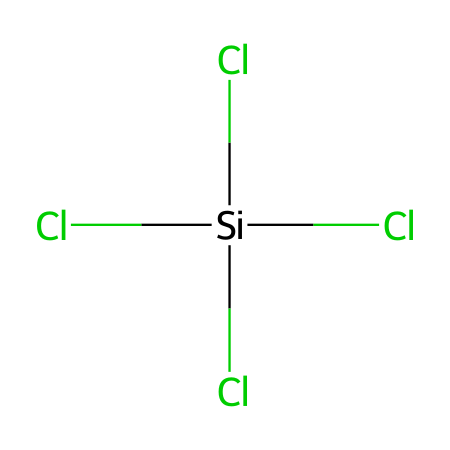What is the name of this chemical? The SMILES representation signifies that the chemical consists of a silicon atom bonded to four chlorine atoms, which is the definition of tetrachlorosilane.
Answer: tetrachlorosilane How many chlorine atoms are present in this molecule? By examining the SMILES structure, we can count four chlorine (Cl) atoms that are directly attached to the silicon atom.
Answer: four What is the central atom in this chemical? The central atom is identified as silicon (Si), which is in the center of the structure bonded to chlorine atoms.
Answer: silicon What is the molecular geometry of tetrachlorosilane? The arrangement of the four identical chlorine atoms around the silicon atom results in a tetrahedral geometry, which is characteristic of molecules with four bonds and no lone pairs.
Answer: tetrahedral How many total bonds are there in this molecule? The structure shows that each of the four chlorine atoms is connected to the silicon atom through a single bond, yielding a total of four bonds within the molecule.
Answer: four Are there any lone pairs on the silicon atom in this molecule? The chemical structure for tetrachlorosilane reveals that all the valence electrons of silicon are engaged in bonding with the chlorine atoms, meaning there are no lone pairs on the silicon.
Answer: no What type of compounds does tetrachlorosilane represent? Tetrachlorosilane fits into the category of silanes, which are compounds containing silicon and hydrogen or silicon bonded to other groups or elements, such as chlorine in this case.
Answer: silanes 